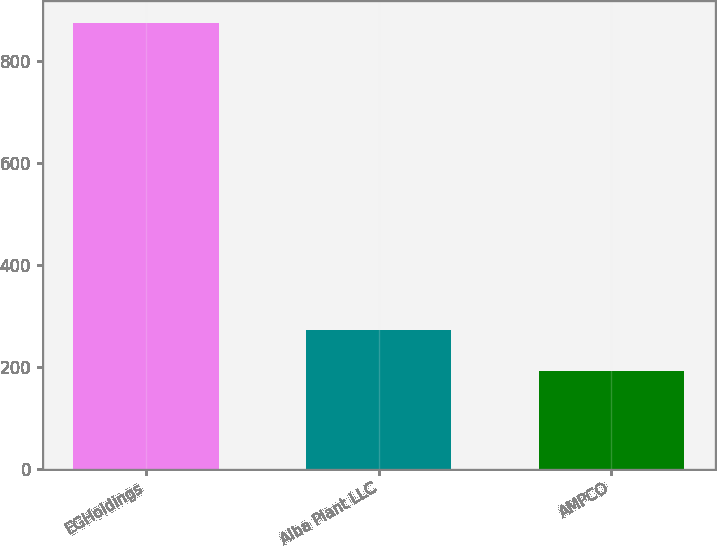Convert chart to OTSL. <chart><loc_0><loc_0><loc_500><loc_500><bar_chart><fcel>EGHoldings<fcel>Alba Plant LLC<fcel>AMPCO<nl><fcel>875<fcel>272<fcel>191<nl></chart> 